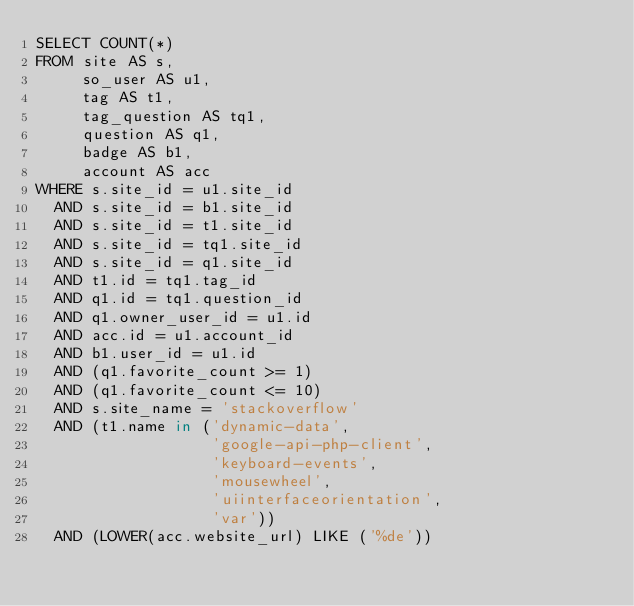Convert code to text. <code><loc_0><loc_0><loc_500><loc_500><_SQL_>SELECT COUNT(*)
FROM site AS s,
     so_user AS u1,
     tag AS t1,
     tag_question AS tq1,
     question AS q1,
     badge AS b1,
     account AS acc
WHERE s.site_id = u1.site_id
  AND s.site_id = b1.site_id
  AND s.site_id = t1.site_id
  AND s.site_id = tq1.site_id
  AND s.site_id = q1.site_id
  AND t1.id = tq1.tag_id
  AND q1.id = tq1.question_id
  AND q1.owner_user_id = u1.id
  AND acc.id = u1.account_id
  AND b1.user_id = u1.id
  AND (q1.favorite_count >= 1)
  AND (q1.favorite_count <= 10)
  AND s.site_name = 'stackoverflow'
  AND (t1.name in ('dynamic-data',
                   'google-api-php-client',
                   'keyboard-events',
                   'mousewheel',
                   'uiinterfaceorientation',
                   'var'))
  AND (LOWER(acc.website_url) LIKE ('%de'))</code> 